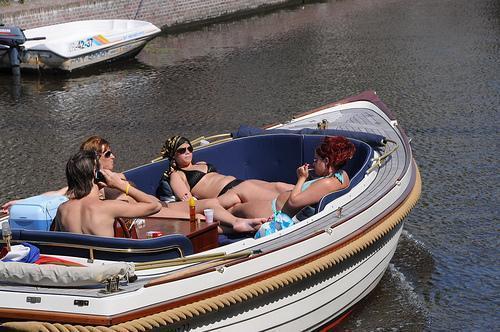How many boats are there?
Give a very brief answer. 2. How many people can be seen?
Give a very brief answer. 4. How many children are wearing orange shirts?
Give a very brief answer. 0. 